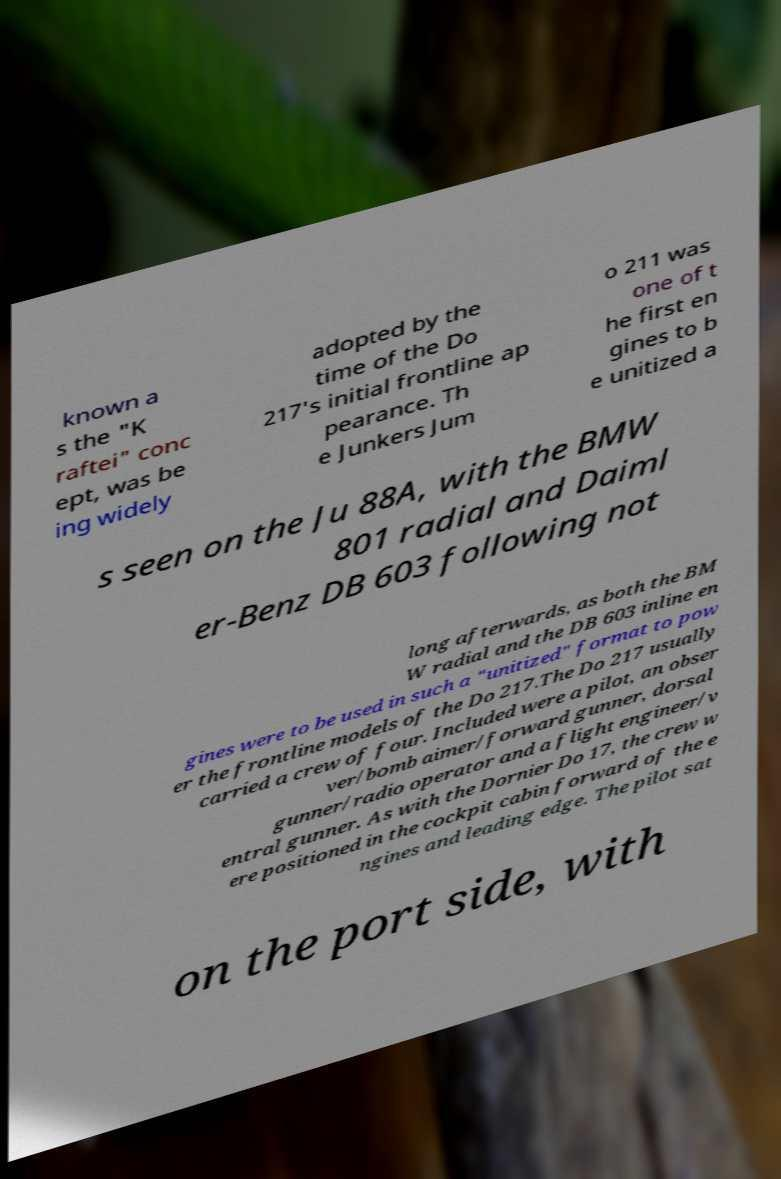For documentation purposes, I need the text within this image transcribed. Could you provide that? known a s the "K raftei" conc ept, was be ing widely adopted by the time of the Do 217's initial frontline ap pearance. Th e Junkers Jum o 211 was one of t he first en gines to b e unitized a s seen on the Ju 88A, with the BMW 801 radial and Daiml er-Benz DB 603 following not long afterwards, as both the BM W radial and the DB 603 inline en gines were to be used in such a "unitized" format to pow er the frontline models of the Do 217.The Do 217 usually carried a crew of four. Included were a pilot, an obser ver/bomb aimer/forward gunner, dorsal gunner/radio operator and a flight engineer/v entral gunner. As with the Dornier Do 17, the crew w ere positioned in the cockpit cabin forward of the e ngines and leading edge. The pilot sat on the port side, with 